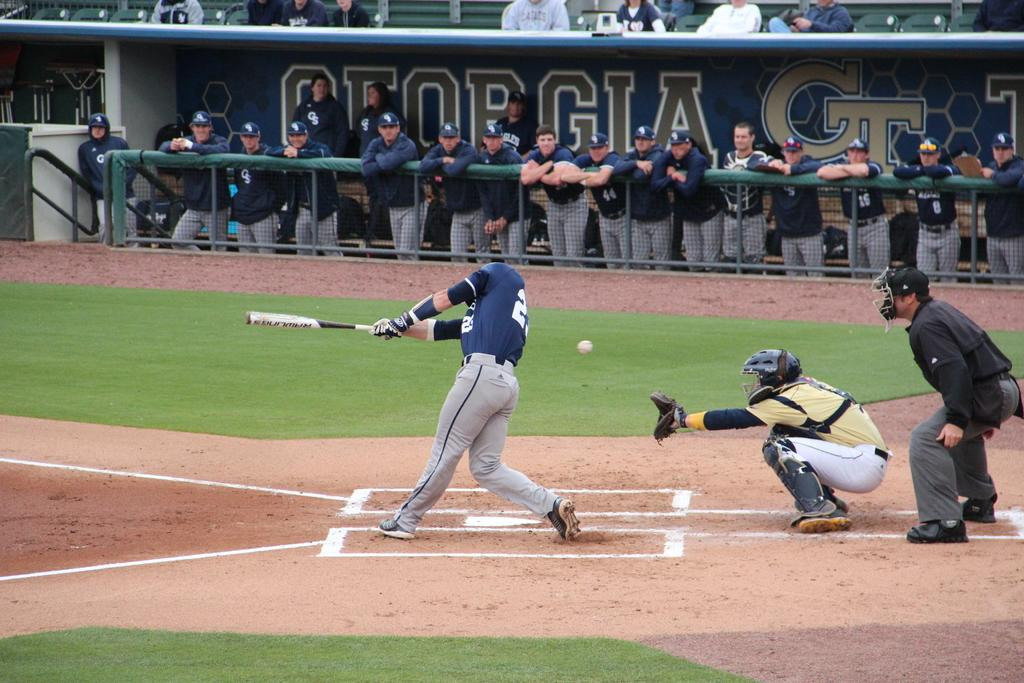<image>
Offer a succinct explanation of the picture presented. Georgia Tech batter swings and misses while on the plate. 